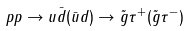Convert formula to latex. <formula><loc_0><loc_0><loc_500><loc_500>p p \rightarrow u \bar { d } ( \bar { u } d ) \rightarrow \tilde { g } \tau ^ { + } ( \tilde { g } \tau ^ { - } )</formula> 